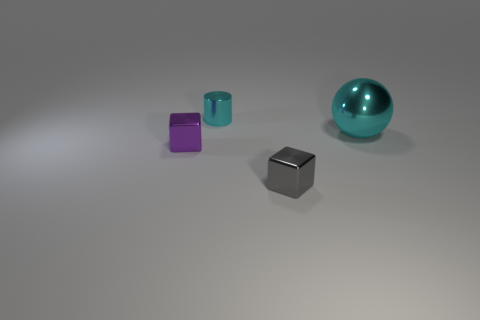Add 3 small brown matte cylinders. How many objects exist? 7 Subtract all cylinders. How many objects are left? 3 Subtract 1 cyan cylinders. How many objects are left? 3 Subtract all cyan rubber cubes. Subtract all purple shiny cubes. How many objects are left? 3 Add 1 cyan metallic balls. How many cyan metallic balls are left? 2 Add 2 small cyan cylinders. How many small cyan cylinders exist? 3 